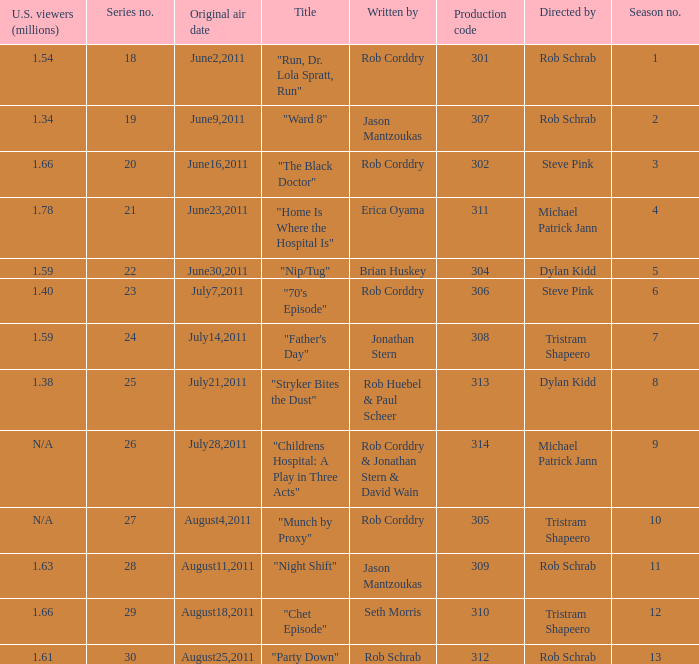At most what number in the series was the episode "chet episode"? 29.0. Could you help me parse every detail presented in this table? {'header': ['U.S. viewers (millions)', 'Series no.', 'Original air date', 'Title', 'Written by', 'Production code', 'Directed by', 'Season no.'], 'rows': [['1.54', '18', 'June2,2011', '"Run, Dr. Lola Spratt, Run"', 'Rob Corddry', '301', 'Rob Schrab', '1'], ['1.34', '19', 'June9,2011', '"Ward 8"', 'Jason Mantzoukas', '307', 'Rob Schrab', '2'], ['1.66', '20', 'June16,2011', '"The Black Doctor"', 'Rob Corddry', '302', 'Steve Pink', '3'], ['1.78', '21', 'June23,2011', '"Home Is Where the Hospital Is"', 'Erica Oyama', '311', 'Michael Patrick Jann', '4'], ['1.59', '22', 'June30,2011', '"Nip/Tug"', 'Brian Huskey', '304', 'Dylan Kidd', '5'], ['1.40', '23', 'July7,2011', '"70\'s Episode"', 'Rob Corddry', '306', 'Steve Pink', '6'], ['1.59', '24', 'July14,2011', '"Father\'s Day"', 'Jonathan Stern', '308', 'Tristram Shapeero', '7'], ['1.38', '25', 'July21,2011', '"Stryker Bites the Dust"', 'Rob Huebel & Paul Scheer', '313', 'Dylan Kidd', '8'], ['N/A', '26', 'July28,2011', '"Childrens Hospital: A Play in Three Acts"', 'Rob Corddry & Jonathan Stern & David Wain', '314', 'Michael Patrick Jann', '9'], ['N/A', '27', 'August4,2011', '"Munch by Proxy"', 'Rob Corddry', '305', 'Tristram Shapeero', '10'], ['1.63', '28', 'August11,2011', '"Night Shift"', 'Jason Mantzoukas', '309', 'Rob Schrab', '11'], ['1.66', '29', 'August18,2011', '"Chet Episode"', 'Seth Morris', '310', 'Tristram Shapeero', '12'], ['1.61', '30', 'August25,2011', '"Party Down"', 'Rob Schrab', '312', 'Rob Schrab', '13']]} 